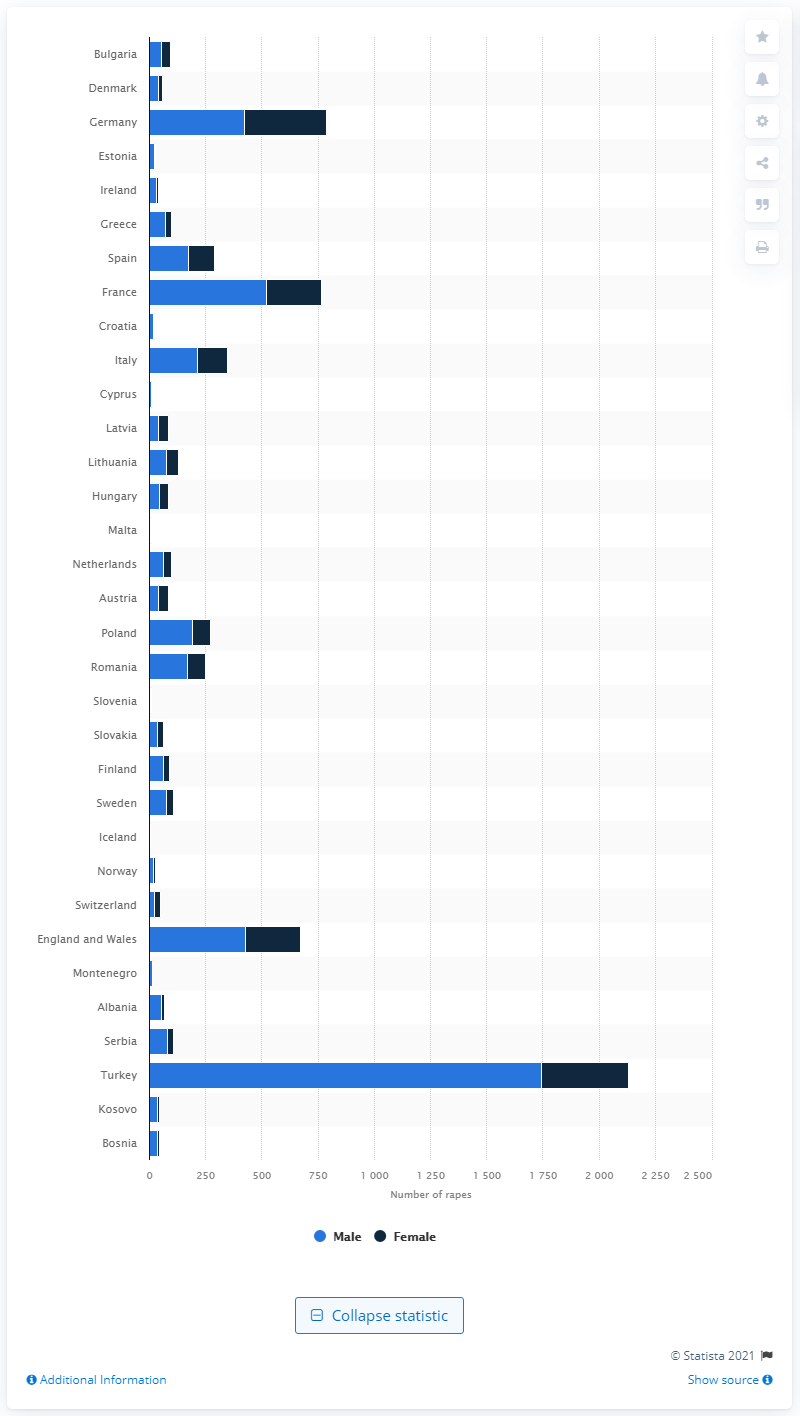Specify some key components in this picture. In 2019, there were 1,744 male rape victims in Turkey. 